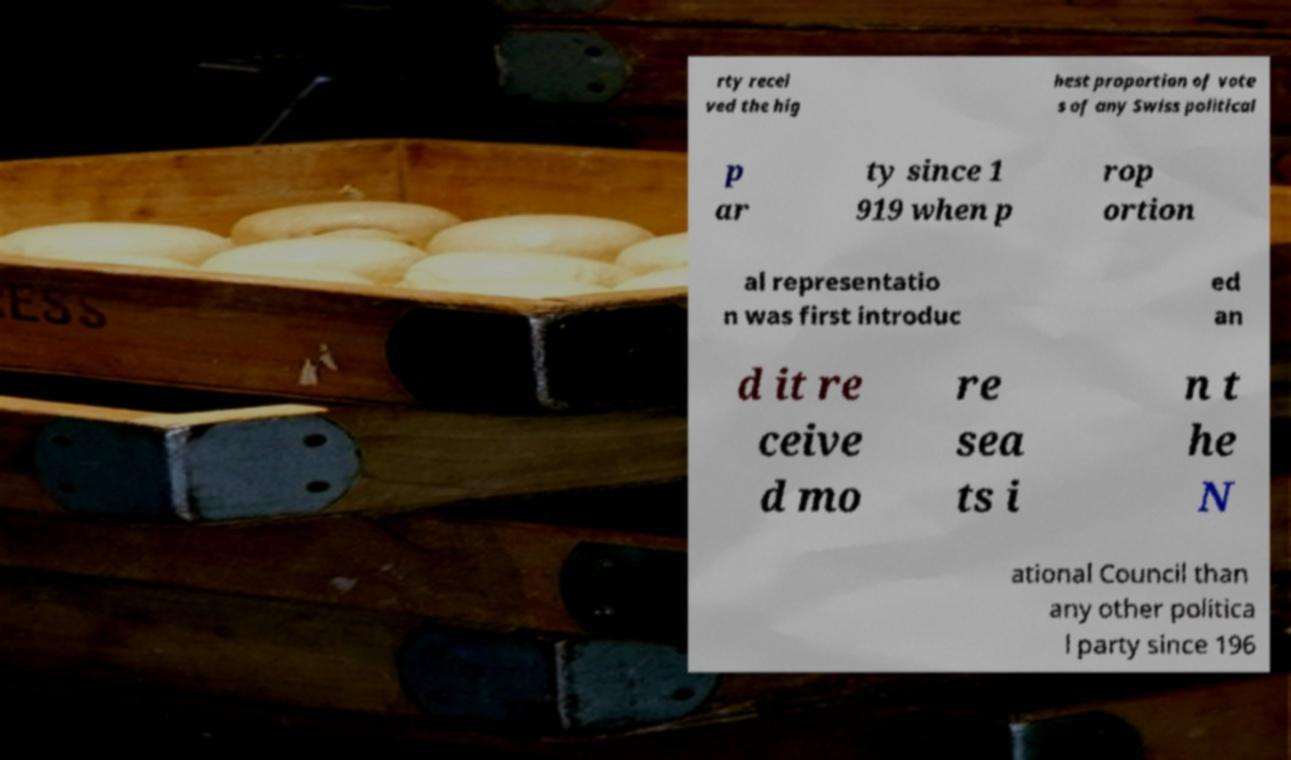Could you extract and type out the text from this image? rty recei ved the hig hest proportion of vote s of any Swiss political p ar ty since 1 919 when p rop ortion al representatio n was first introduc ed an d it re ceive d mo re sea ts i n t he N ational Council than any other politica l party since 196 